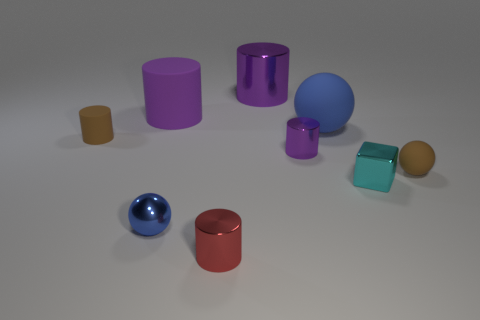Is there anything else that has the same shape as the small cyan shiny object?
Your response must be concise. No. Is the size of the brown matte cylinder the same as the blue matte object?
Provide a short and direct response. No. There is a tiny purple object that is the same shape as the tiny red shiny thing; what is its material?
Make the answer very short. Metal. How many metallic objects have the same size as the purple rubber cylinder?
Your answer should be very brief. 1. What color is the large cylinder that is made of the same material as the small cyan block?
Ensure brevity in your answer.  Purple. Are there fewer blue rubber blocks than red metallic things?
Ensure brevity in your answer.  Yes. What number of purple objects are either big metallic objects or tiny matte cubes?
Provide a succinct answer. 1. How many blue objects are in front of the large blue sphere and right of the big purple shiny thing?
Your answer should be compact. 0. Do the brown cylinder and the big blue ball have the same material?
Provide a short and direct response. Yes. What is the shape of the purple object that is the same size as the shiny sphere?
Make the answer very short. Cylinder. 